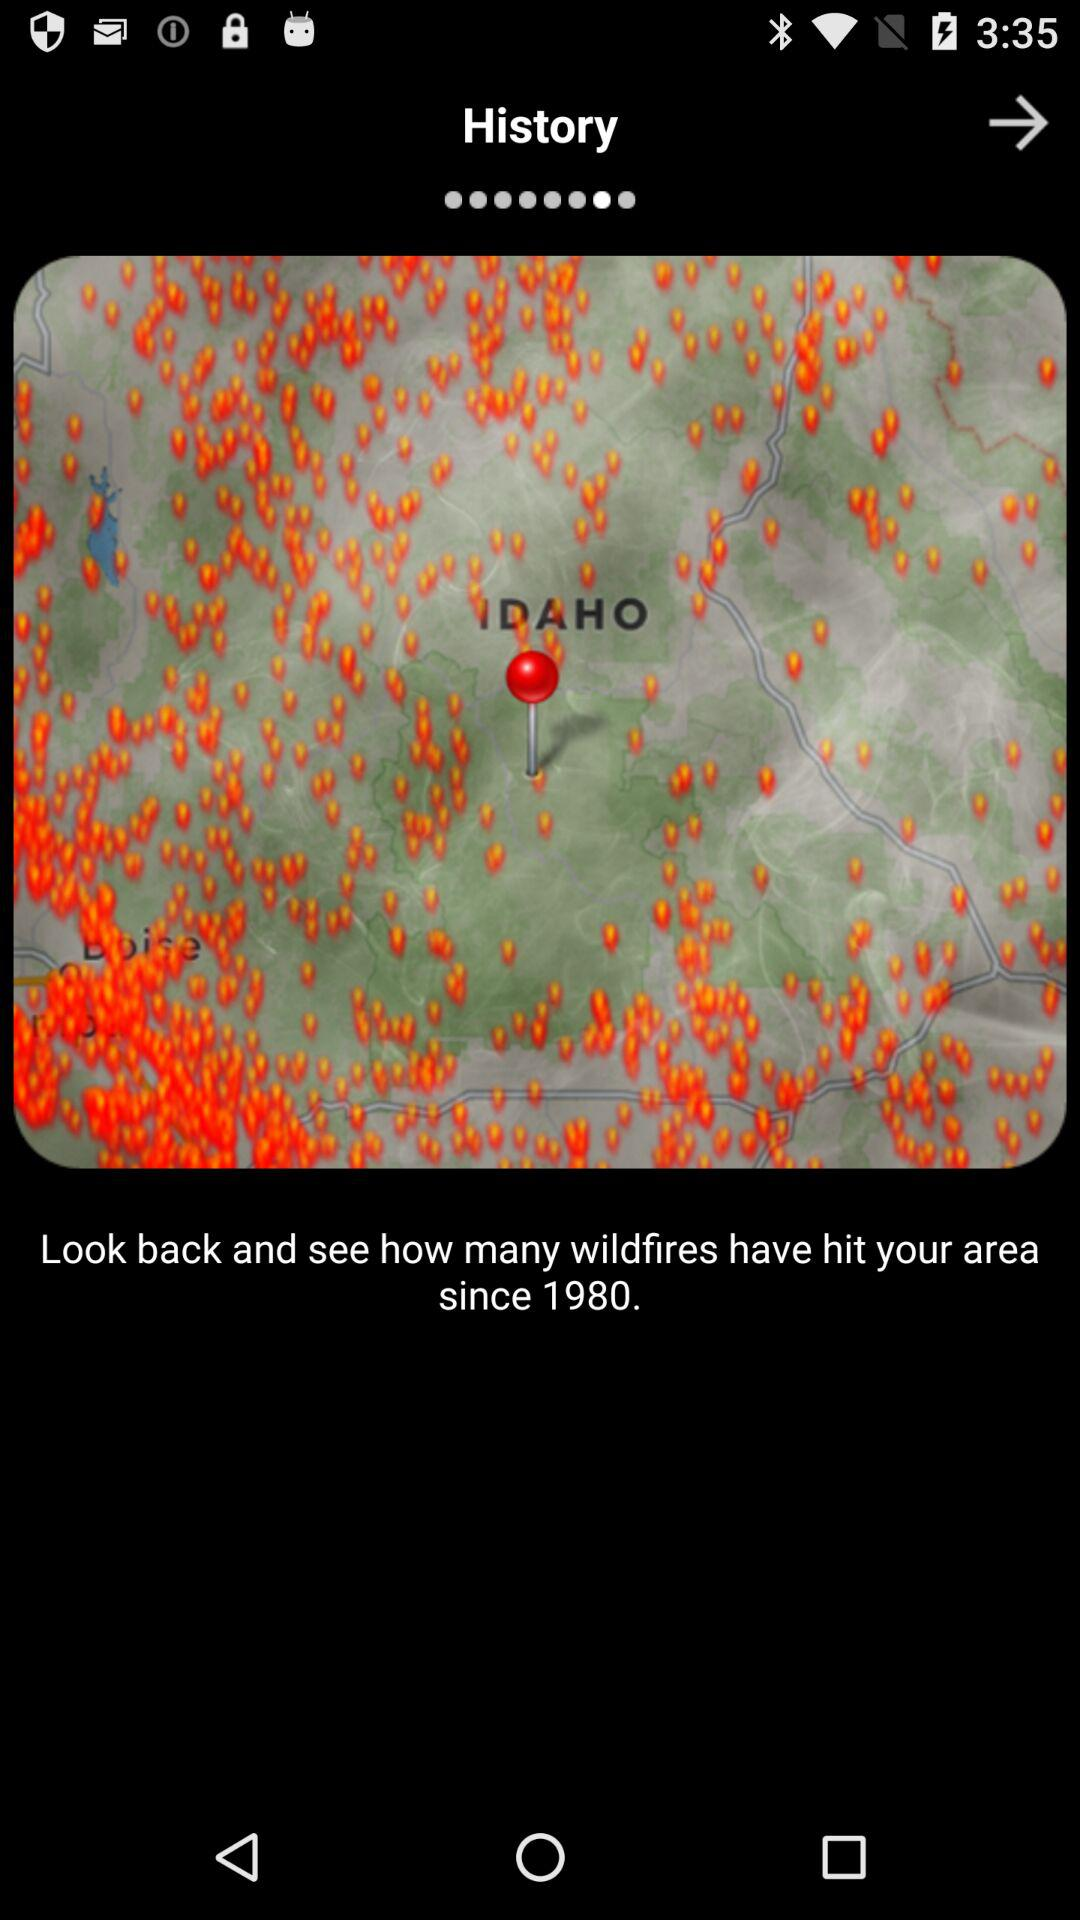What is the mentioned year? The mentioned year is 1980. 